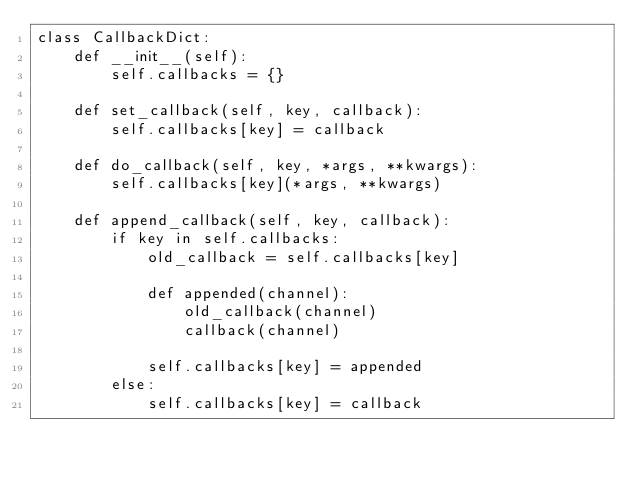<code> <loc_0><loc_0><loc_500><loc_500><_Python_>class CallbackDict:
    def __init__(self):
        self.callbacks = {}
    
    def set_callback(self, key, callback):
        self.callbacks[key] = callback
    
    def do_callback(self, key, *args, **kwargs):
        self.callbacks[key](*args, **kwargs)
        
    def append_callback(self, key, callback):
        if key in self.callbacks:
            old_callback = self.callbacks[key]
            
            def appended(channel):
                old_callback(channel)
                callback(channel)
            
            self.callbacks[key] = appended
        else:
            self.callbacks[key] = callback</code> 